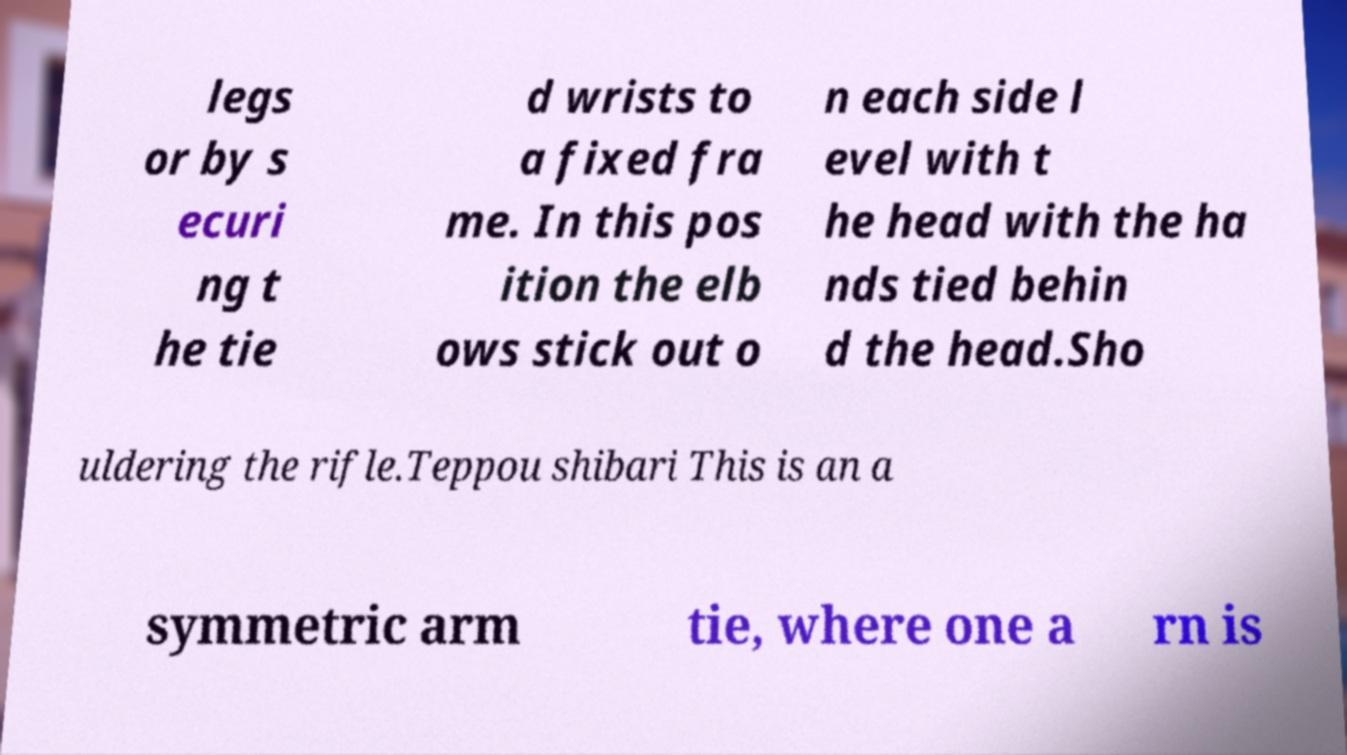There's text embedded in this image that I need extracted. Can you transcribe it verbatim? legs or by s ecuri ng t he tie d wrists to a fixed fra me. In this pos ition the elb ows stick out o n each side l evel with t he head with the ha nds tied behin d the head.Sho uldering the rifle.Teppou shibari This is an a symmetric arm tie, where one a rn is 